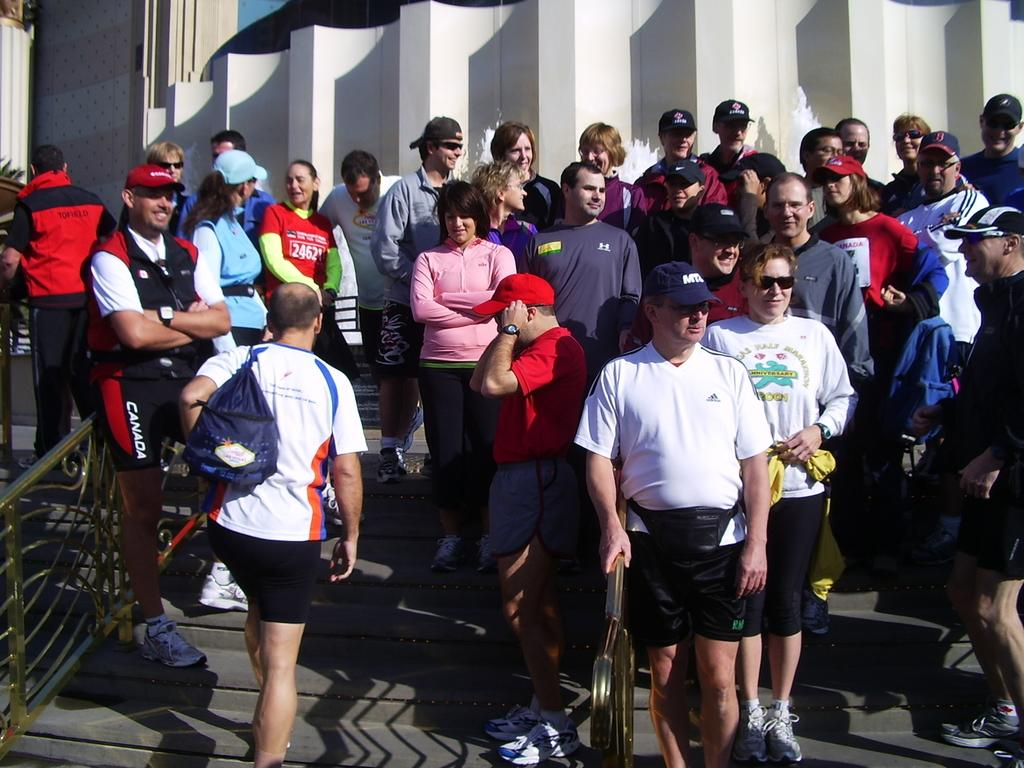What is the main subject of the image? The main subject of the image is a group of people. Where are the people located in the image? The people are standing on the steps. What other objects or structures are visible in the image? There is a fence in the image. What can be seen in the background of the image? There is a white color wall in the background of the image. What type of hair is the mother combing in the image? There is no mother or hair present in the image. Can you tell me how many cubs are visible in the image? There are no cubs present in the image. 